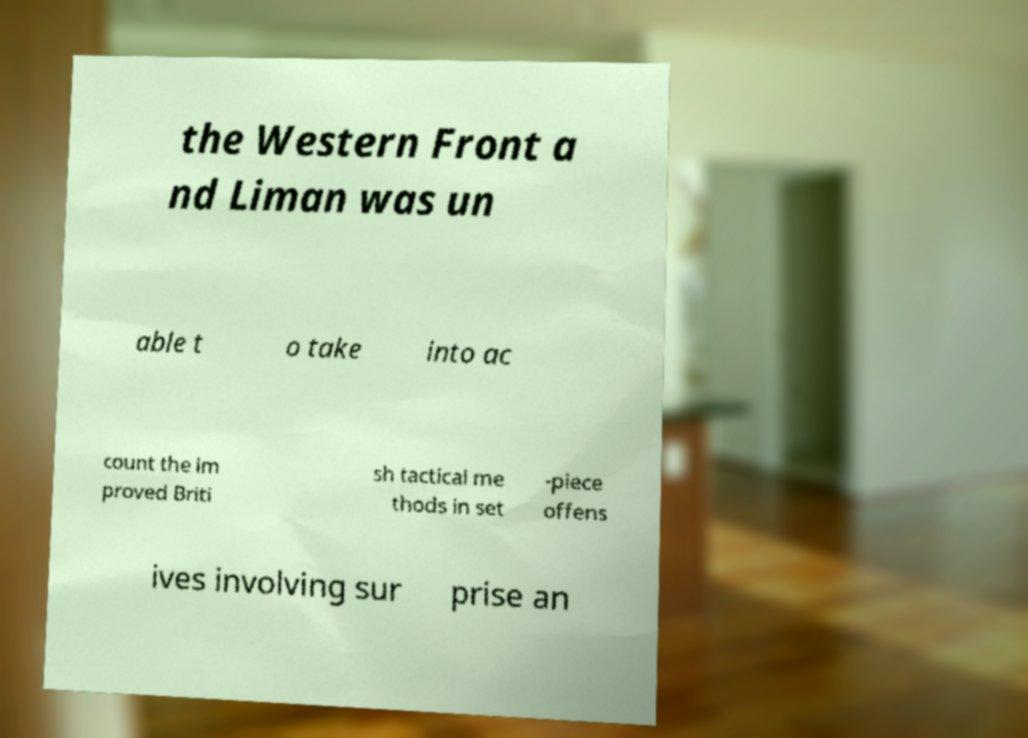Could you assist in decoding the text presented in this image and type it out clearly? the Western Front a nd Liman was un able t o take into ac count the im proved Briti sh tactical me thods in set -piece offens ives involving sur prise an 